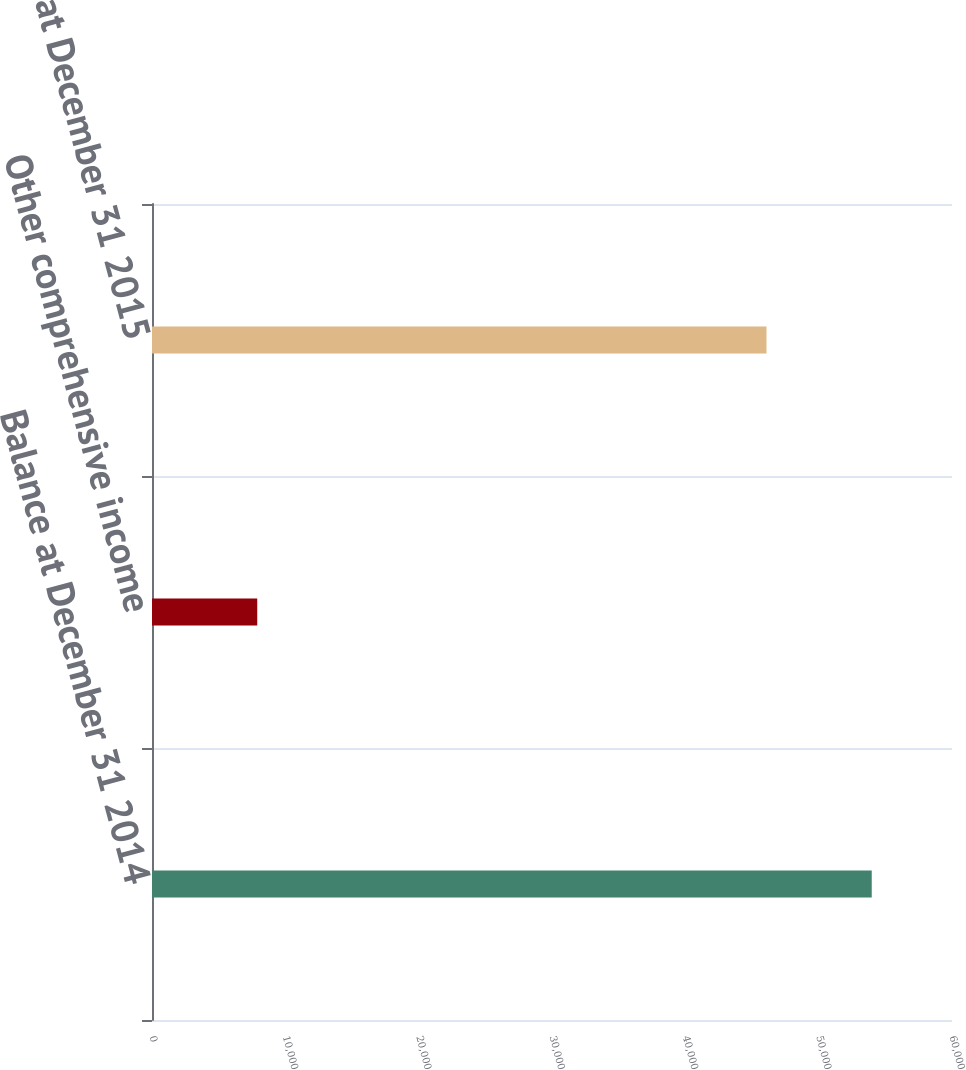Convert chart. <chart><loc_0><loc_0><loc_500><loc_500><bar_chart><fcel>Balance at December 31 2014<fcel>Other comprehensive income<fcel>Balance at December 31 2015<nl><fcel>53980<fcel>7893<fcel>46087<nl></chart> 